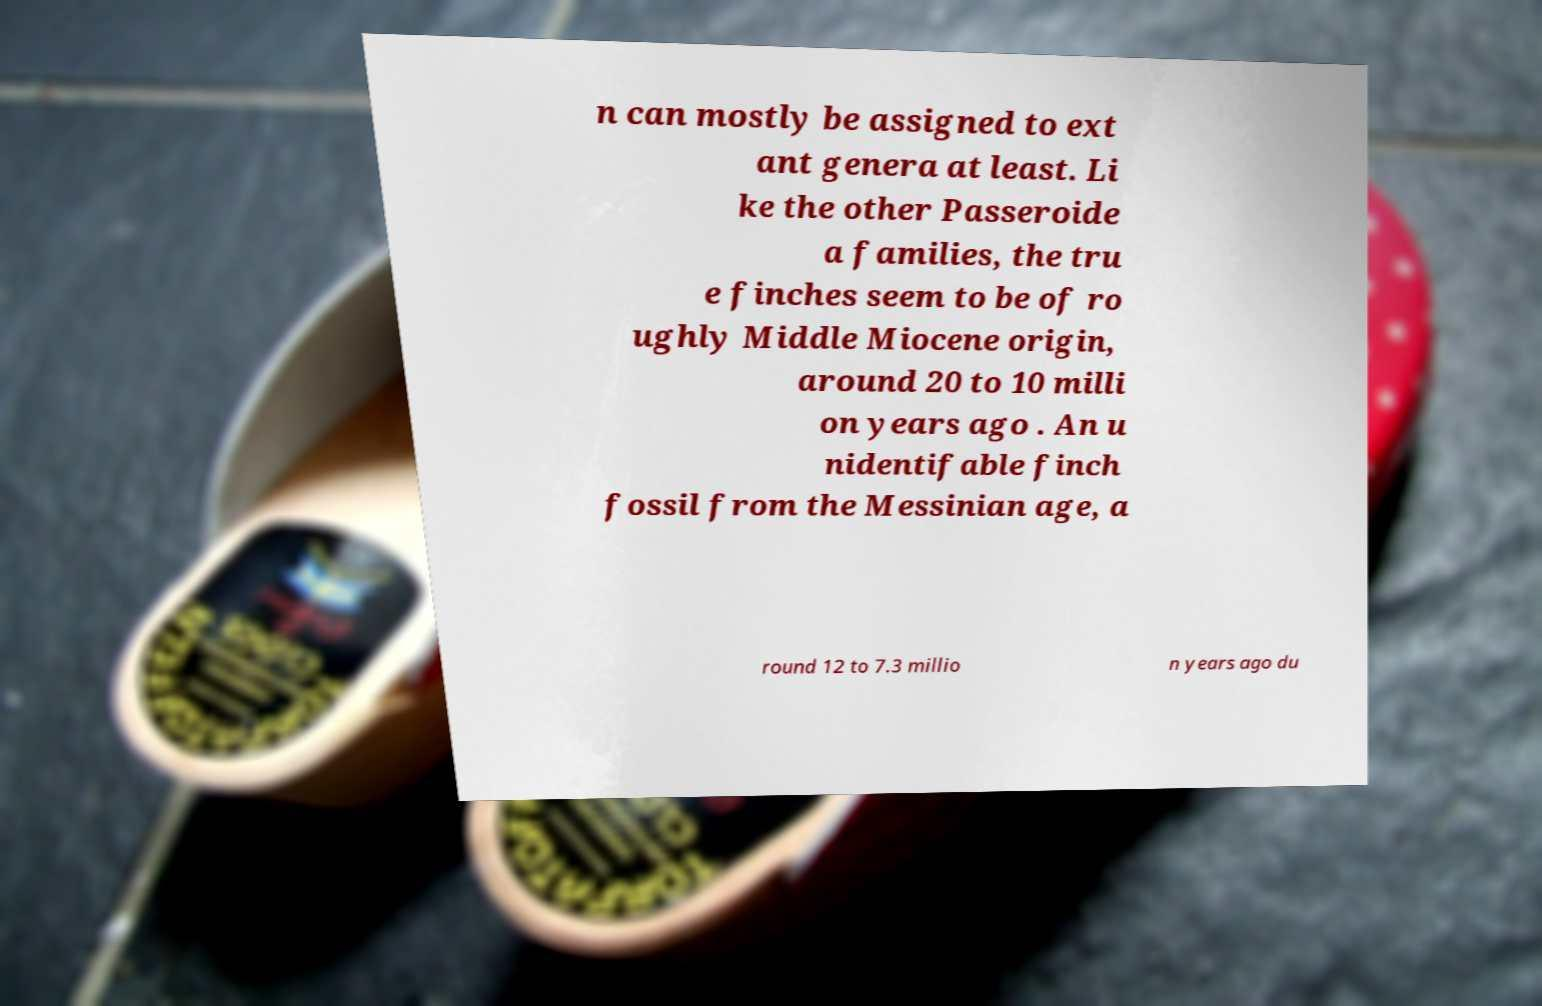Please identify and transcribe the text found in this image. n can mostly be assigned to ext ant genera at least. Li ke the other Passeroide a families, the tru e finches seem to be of ro ughly Middle Miocene origin, around 20 to 10 milli on years ago . An u nidentifable finch fossil from the Messinian age, a round 12 to 7.3 millio n years ago du 